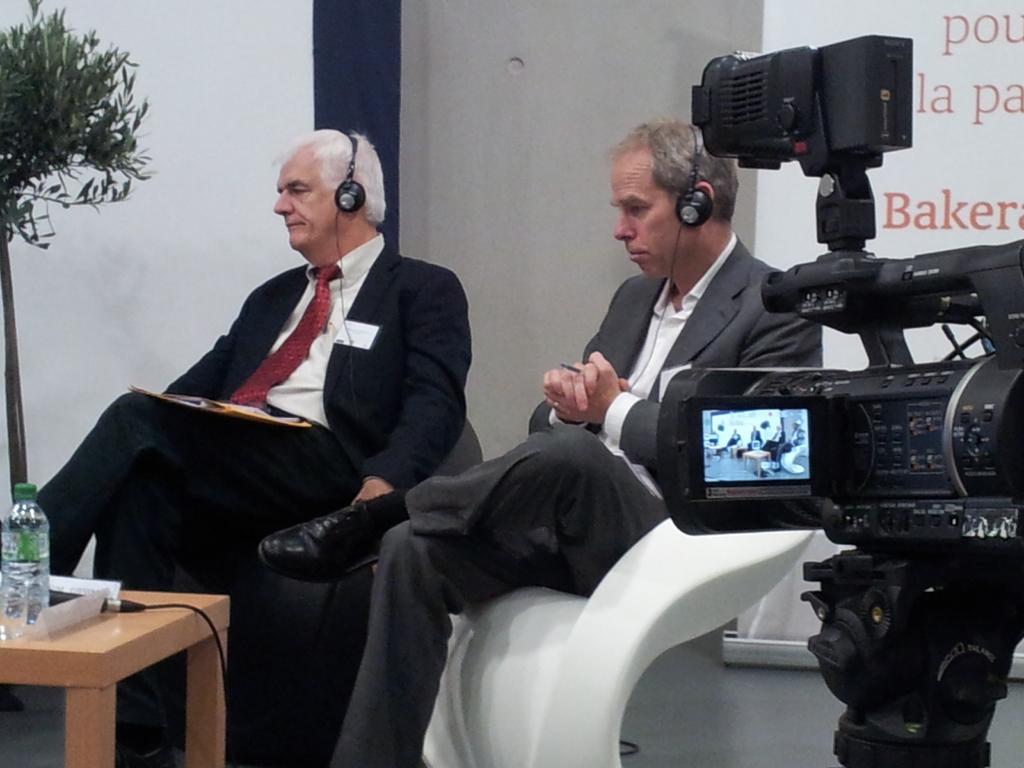Describe this image in one or two sentences. In this picture we can see two persons sitting on the chairs. This is the camera and there is a table. On the table there is a bottle, and mike. On the background we can see a wall. And this is the plant. Even we can see the screen here. 